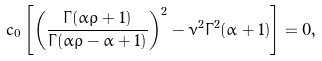<formula> <loc_0><loc_0><loc_500><loc_500>c _ { 0 } \left [ \left ( \frac { \Gamma ( \alpha \rho + 1 ) } { \Gamma ( \alpha \rho - \alpha + 1 ) } \right ) ^ { 2 } - \nu ^ { 2 } \Gamma ^ { 2 } ( \alpha + 1 ) \right ] = 0 ,</formula> 